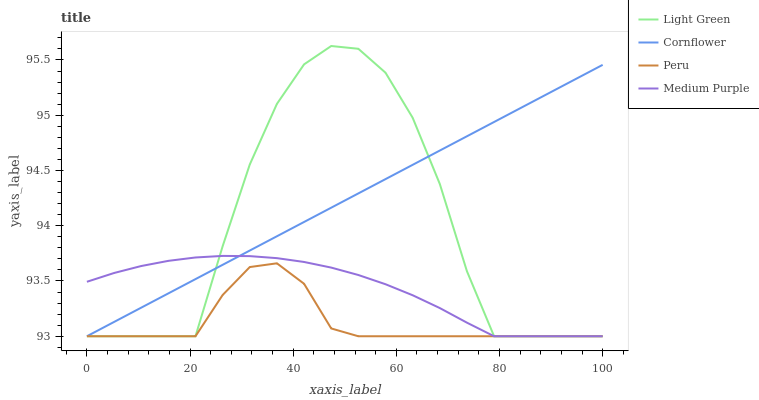Does Peru have the minimum area under the curve?
Answer yes or no. Yes. Does Cornflower have the maximum area under the curve?
Answer yes or no. Yes. Does Cornflower have the minimum area under the curve?
Answer yes or no. No. Does Peru have the maximum area under the curve?
Answer yes or no. No. Is Cornflower the smoothest?
Answer yes or no. Yes. Is Light Green the roughest?
Answer yes or no. Yes. Is Peru the smoothest?
Answer yes or no. No. Is Peru the roughest?
Answer yes or no. No. Does Medium Purple have the lowest value?
Answer yes or no. Yes. Does Light Green have the highest value?
Answer yes or no. Yes. Does Cornflower have the highest value?
Answer yes or no. No. Does Peru intersect Medium Purple?
Answer yes or no. Yes. Is Peru less than Medium Purple?
Answer yes or no. No. Is Peru greater than Medium Purple?
Answer yes or no. No. 